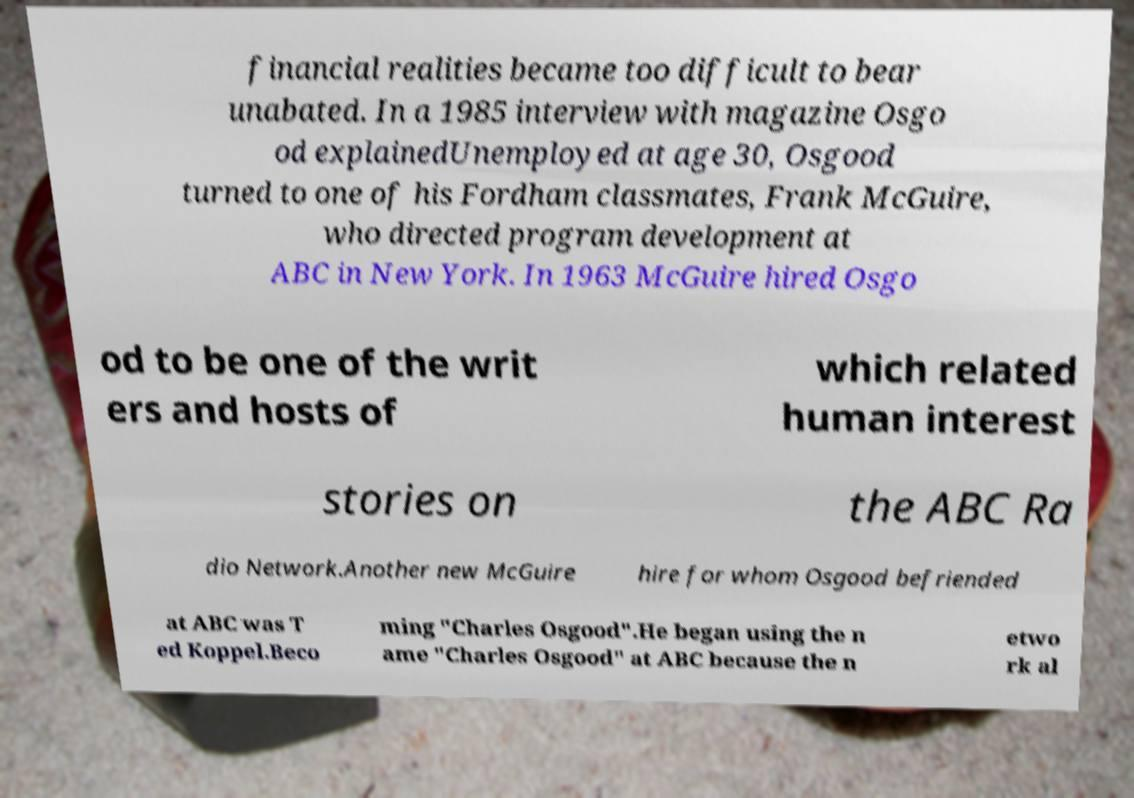Please read and relay the text visible in this image. What does it say? financial realities became too difficult to bear unabated. In a 1985 interview with magazine Osgo od explainedUnemployed at age 30, Osgood turned to one of his Fordham classmates, Frank McGuire, who directed program development at ABC in New York. In 1963 McGuire hired Osgo od to be one of the writ ers and hosts of which related human interest stories on the ABC Ra dio Network.Another new McGuire hire for whom Osgood befriended at ABC was T ed Koppel.Beco ming "Charles Osgood".He began using the n ame "Charles Osgood" at ABC because the n etwo rk al 